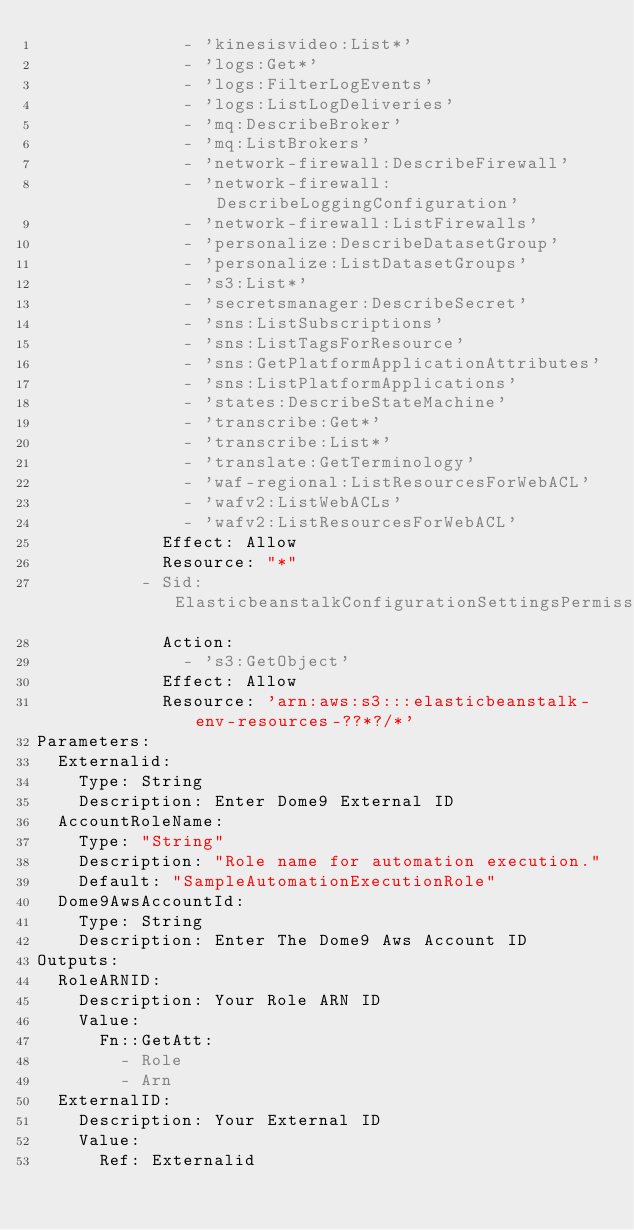<code> <loc_0><loc_0><loc_500><loc_500><_YAML_>              - 'kinesisvideo:List*'
              - 'logs:Get*'
              - 'logs:FilterLogEvents'
              - 'logs:ListLogDeliveries'
              - 'mq:DescribeBroker'
              - 'mq:ListBrokers'
              - 'network-firewall:DescribeFirewall'
              - 'network-firewall:DescribeLoggingConfiguration'
              - 'network-firewall:ListFirewalls'
              - 'personalize:DescribeDatasetGroup'
              - 'personalize:ListDatasetGroups'
              - 's3:List*'
              - 'secretsmanager:DescribeSecret'
              - 'sns:ListSubscriptions'
              - 'sns:ListTagsForResource'
              - 'sns:GetPlatformApplicationAttributes'
              - 'sns:ListPlatformApplications'
              - 'states:DescribeStateMachine'
              - 'transcribe:Get*'
              - 'transcribe:List*'
              - 'translate:GetTerminology'
              - 'waf-regional:ListResourcesForWebACL'
              - 'wafv2:ListWebACLs'
              - 'wafv2:ListResourcesForWebACL'
            Effect: Allow
            Resource: "*"
          - Sid: ElasticbeanstalkConfigurationSettingsPermission
            Action:
              - 's3:GetObject'
            Effect: Allow
            Resource: 'arn:aws:s3:::elasticbeanstalk-env-resources-??*?/*'
Parameters:
  Externalid:
    Type: String
    Description: Enter Dome9 External ID
  AccountRoleName:
    Type: "String"
    Description: "Role name for automation execution."
    Default: "SampleAutomationExecutionRole"
  Dome9AwsAccountId:
    Type: String
    Description: Enter The Dome9 Aws Account ID
Outputs:
  RoleARNID:
    Description: Your Role ARN ID
    Value:
      Fn::GetAtt:
        - Role
        - Arn
  ExternalID:
    Description: Your External ID
    Value:
      Ref: Externalid
</code> 